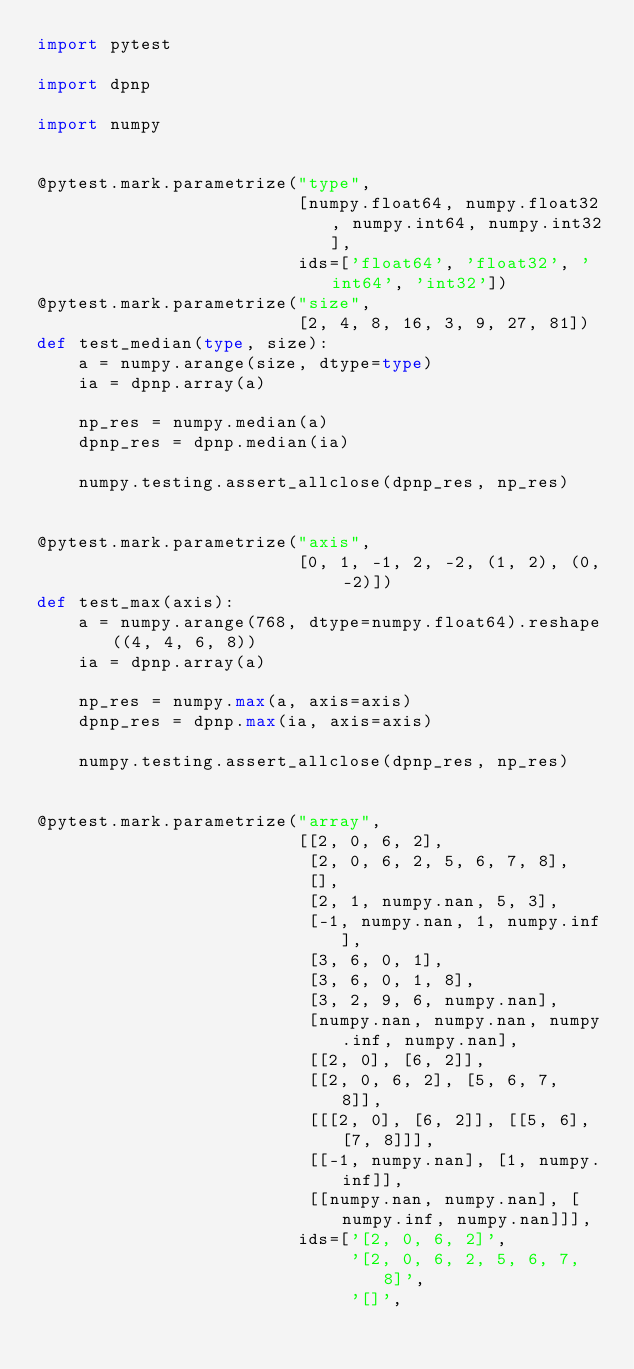<code> <loc_0><loc_0><loc_500><loc_500><_Python_>import pytest

import dpnp

import numpy


@pytest.mark.parametrize("type",
                         [numpy.float64, numpy.float32, numpy.int64, numpy.int32],
                         ids=['float64', 'float32', 'int64', 'int32'])
@pytest.mark.parametrize("size",
                         [2, 4, 8, 16, 3, 9, 27, 81])
def test_median(type, size):
    a = numpy.arange(size, dtype=type)
    ia = dpnp.array(a)

    np_res = numpy.median(a)
    dpnp_res = dpnp.median(ia)

    numpy.testing.assert_allclose(dpnp_res, np_res)


@pytest.mark.parametrize("axis",
                         [0, 1, -1, 2, -2, (1, 2), (0, -2)])
def test_max(axis):
    a = numpy.arange(768, dtype=numpy.float64).reshape((4, 4, 6, 8))
    ia = dpnp.array(a)

    np_res = numpy.max(a, axis=axis)
    dpnp_res = dpnp.max(ia, axis=axis)

    numpy.testing.assert_allclose(dpnp_res, np_res)


@pytest.mark.parametrize("array",
                         [[2, 0, 6, 2],
                          [2, 0, 6, 2, 5, 6, 7, 8],
                          [],
                          [2, 1, numpy.nan, 5, 3],
                          [-1, numpy.nan, 1, numpy.inf],
                          [3, 6, 0, 1],
                          [3, 6, 0, 1, 8],
                          [3, 2, 9, 6, numpy.nan],
                          [numpy.nan, numpy.nan, numpy.inf, numpy.nan],
                          [[2, 0], [6, 2]],
                          [[2, 0, 6, 2], [5, 6, 7, 8]],
                          [[[2, 0], [6, 2]], [[5, 6], [7, 8]]],
                          [[-1, numpy.nan], [1, numpy.inf]],
                          [[numpy.nan, numpy.nan], [numpy.inf, numpy.nan]]],
                         ids=['[2, 0, 6, 2]',
                              '[2, 0, 6, 2, 5, 6, 7, 8]',
                              '[]',</code> 